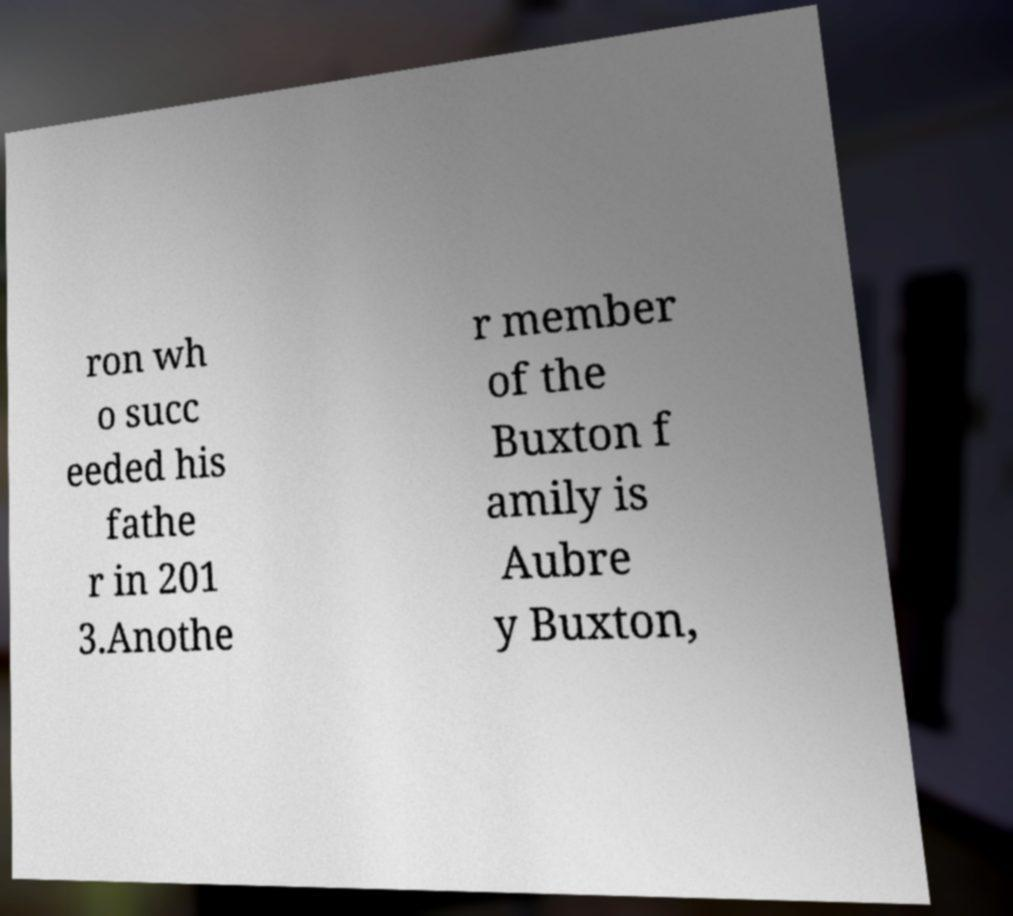For documentation purposes, I need the text within this image transcribed. Could you provide that? ron wh o succ eeded his fathe r in 201 3.Anothe r member of the Buxton f amily is Aubre y Buxton, 